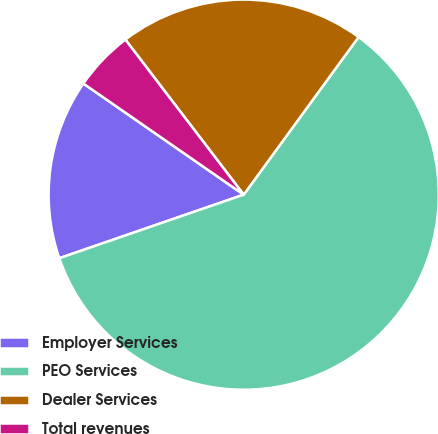<chart> <loc_0><loc_0><loc_500><loc_500><pie_chart><fcel>Employer Services<fcel>PEO Services<fcel>Dealer Services<fcel>Total revenues<nl><fcel>14.93%<fcel>59.7%<fcel>20.4%<fcel>4.98%<nl></chart> 